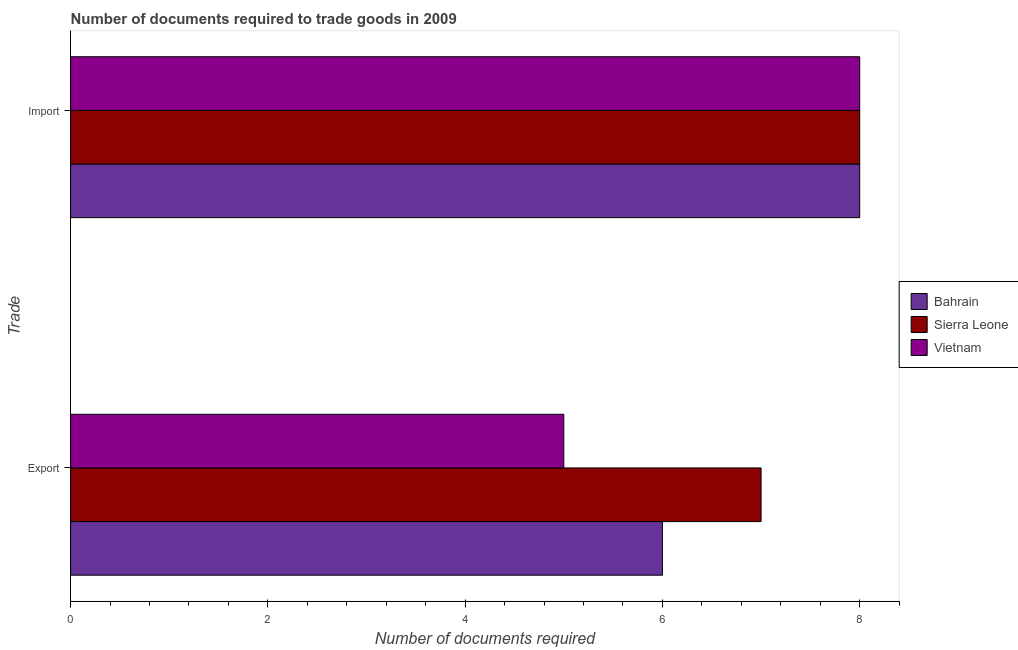How many groups of bars are there?
Provide a short and direct response. 2. Are the number of bars per tick equal to the number of legend labels?
Offer a terse response. Yes. Are the number of bars on each tick of the Y-axis equal?
Your answer should be compact. Yes. How many bars are there on the 1st tick from the top?
Make the answer very short. 3. How many bars are there on the 1st tick from the bottom?
Keep it short and to the point. 3. What is the label of the 1st group of bars from the top?
Your answer should be compact. Import. Across all countries, what is the maximum number of documents required to import goods?
Ensure brevity in your answer.  8. Across all countries, what is the minimum number of documents required to import goods?
Your response must be concise. 8. In which country was the number of documents required to import goods maximum?
Give a very brief answer. Bahrain. In which country was the number of documents required to export goods minimum?
Ensure brevity in your answer.  Vietnam. What is the total number of documents required to export goods in the graph?
Ensure brevity in your answer.  18. What is the difference between the number of documents required to export goods in Vietnam and that in Bahrain?
Your answer should be compact. -1. What is the difference between the number of documents required to export goods in Sierra Leone and the number of documents required to import goods in Vietnam?
Your answer should be very brief. -1. What is the difference between the number of documents required to import goods and number of documents required to export goods in Sierra Leone?
Your answer should be very brief. 1. What is the ratio of the number of documents required to export goods in Vietnam to that in Bahrain?
Your answer should be compact. 0.83. In how many countries, is the number of documents required to import goods greater than the average number of documents required to import goods taken over all countries?
Ensure brevity in your answer.  0. What does the 3rd bar from the top in Export represents?
Your response must be concise. Bahrain. What does the 3rd bar from the bottom in Export represents?
Your response must be concise. Vietnam. What is the difference between two consecutive major ticks on the X-axis?
Make the answer very short. 2. Are the values on the major ticks of X-axis written in scientific E-notation?
Offer a terse response. No. Where does the legend appear in the graph?
Your response must be concise. Center right. How many legend labels are there?
Keep it short and to the point. 3. What is the title of the graph?
Ensure brevity in your answer.  Number of documents required to trade goods in 2009. What is the label or title of the X-axis?
Ensure brevity in your answer.  Number of documents required. What is the label or title of the Y-axis?
Ensure brevity in your answer.  Trade. What is the Number of documents required of Bahrain in Export?
Ensure brevity in your answer.  6. What is the Number of documents required in Sierra Leone in Export?
Provide a short and direct response. 7. What is the Number of documents required of Bahrain in Import?
Ensure brevity in your answer.  8. Across all Trade, what is the maximum Number of documents required in Bahrain?
Ensure brevity in your answer.  8. Across all Trade, what is the maximum Number of documents required of Sierra Leone?
Your answer should be very brief. 8. Across all Trade, what is the maximum Number of documents required of Vietnam?
Keep it short and to the point. 8. Across all Trade, what is the minimum Number of documents required in Bahrain?
Make the answer very short. 6. What is the total Number of documents required in Bahrain in the graph?
Provide a succinct answer. 14. What is the total Number of documents required of Vietnam in the graph?
Your answer should be very brief. 13. What is the difference between the Number of documents required in Vietnam in Export and that in Import?
Provide a short and direct response. -3. What is the difference between the Number of documents required in Bahrain in Export and the Number of documents required in Sierra Leone in Import?
Offer a terse response. -2. What is the difference between the Number of documents required of Bahrain in Export and the Number of documents required of Vietnam in Import?
Give a very brief answer. -2. What is the difference between the Number of documents required of Sierra Leone in Export and the Number of documents required of Vietnam in Import?
Make the answer very short. -1. What is the average Number of documents required in Bahrain per Trade?
Provide a short and direct response. 7. What is the average Number of documents required in Sierra Leone per Trade?
Your answer should be very brief. 7.5. What is the difference between the Number of documents required of Bahrain and Number of documents required of Vietnam in Export?
Offer a terse response. 1. What is the difference between the Number of documents required in Bahrain and Number of documents required in Sierra Leone in Import?
Your answer should be compact. 0. What is the ratio of the Number of documents required in Sierra Leone in Export to that in Import?
Offer a terse response. 0.88. What is the ratio of the Number of documents required in Vietnam in Export to that in Import?
Make the answer very short. 0.62. What is the difference between the highest and the second highest Number of documents required in Bahrain?
Your answer should be compact. 2. What is the difference between the highest and the second highest Number of documents required of Sierra Leone?
Your response must be concise. 1. What is the difference between the highest and the lowest Number of documents required in Bahrain?
Your response must be concise. 2. What is the difference between the highest and the lowest Number of documents required of Sierra Leone?
Provide a short and direct response. 1. 